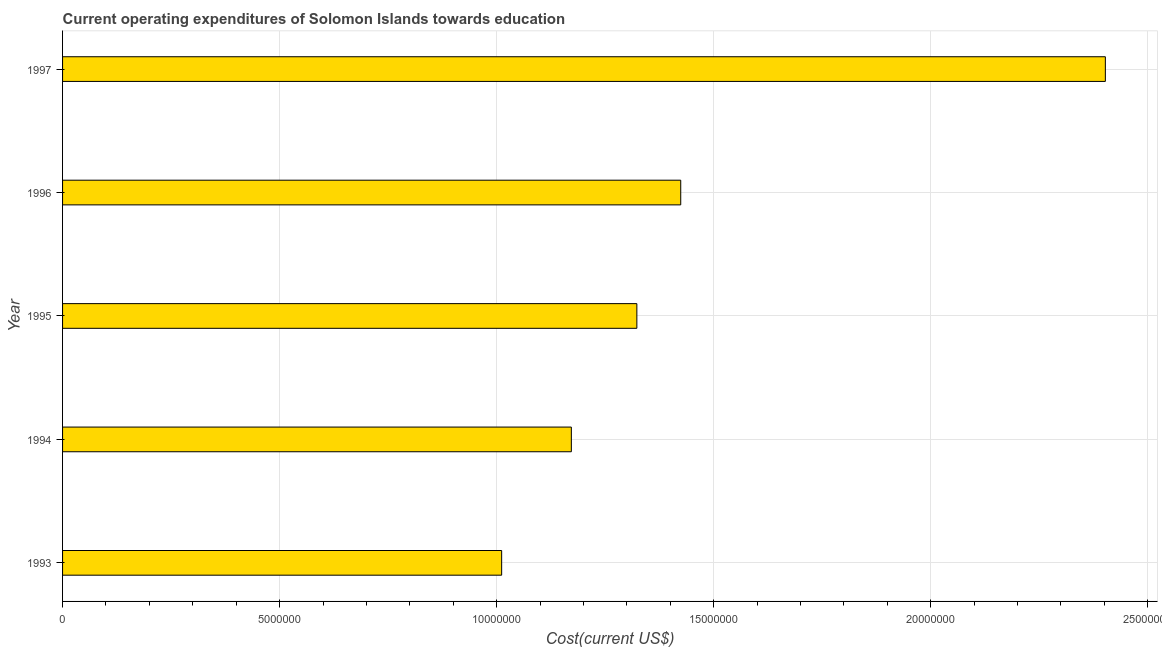Does the graph contain any zero values?
Ensure brevity in your answer.  No. Does the graph contain grids?
Your answer should be very brief. Yes. What is the title of the graph?
Your response must be concise. Current operating expenditures of Solomon Islands towards education. What is the label or title of the X-axis?
Give a very brief answer. Cost(current US$). What is the education expenditure in 1995?
Your answer should be compact. 1.32e+07. Across all years, what is the maximum education expenditure?
Offer a very short reply. 2.40e+07. Across all years, what is the minimum education expenditure?
Offer a very short reply. 1.01e+07. In which year was the education expenditure maximum?
Your response must be concise. 1997. What is the sum of the education expenditure?
Keep it short and to the point. 7.33e+07. What is the difference between the education expenditure in 1994 and 1996?
Make the answer very short. -2.52e+06. What is the average education expenditure per year?
Offer a terse response. 1.47e+07. What is the median education expenditure?
Make the answer very short. 1.32e+07. In how many years, is the education expenditure greater than 12000000 US$?
Offer a terse response. 3. What is the ratio of the education expenditure in 1994 to that in 1996?
Offer a very short reply. 0.82. Is the education expenditure in 1995 less than that in 1996?
Keep it short and to the point. Yes. Is the difference between the education expenditure in 1993 and 1997 greater than the difference between any two years?
Make the answer very short. Yes. What is the difference between the highest and the second highest education expenditure?
Your answer should be very brief. 9.78e+06. Is the sum of the education expenditure in 1994 and 1997 greater than the maximum education expenditure across all years?
Your response must be concise. Yes. What is the difference between the highest and the lowest education expenditure?
Your response must be concise. 1.39e+07. In how many years, is the education expenditure greater than the average education expenditure taken over all years?
Make the answer very short. 1. How many bars are there?
Provide a short and direct response. 5. How many years are there in the graph?
Your answer should be compact. 5. What is the difference between two consecutive major ticks on the X-axis?
Provide a short and direct response. 5.00e+06. What is the Cost(current US$) of 1993?
Provide a succinct answer. 1.01e+07. What is the Cost(current US$) of 1994?
Provide a succinct answer. 1.17e+07. What is the Cost(current US$) in 1995?
Your response must be concise. 1.32e+07. What is the Cost(current US$) in 1996?
Your response must be concise. 1.42e+07. What is the Cost(current US$) in 1997?
Provide a succinct answer. 2.40e+07. What is the difference between the Cost(current US$) in 1993 and 1994?
Your response must be concise. -1.61e+06. What is the difference between the Cost(current US$) in 1993 and 1995?
Provide a short and direct response. -3.11e+06. What is the difference between the Cost(current US$) in 1993 and 1996?
Keep it short and to the point. -4.13e+06. What is the difference between the Cost(current US$) in 1993 and 1997?
Your response must be concise. -1.39e+07. What is the difference between the Cost(current US$) in 1994 and 1995?
Offer a terse response. -1.51e+06. What is the difference between the Cost(current US$) in 1994 and 1996?
Offer a very short reply. -2.52e+06. What is the difference between the Cost(current US$) in 1994 and 1997?
Your answer should be very brief. -1.23e+07. What is the difference between the Cost(current US$) in 1995 and 1996?
Ensure brevity in your answer.  -1.01e+06. What is the difference between the Cost(current US$) in 1995 and 1997?
Keep it short and to the point. -1.08e+07. What is the difference between the Cost(current US$) in 1996 and 1997?
Offer a very short reply. -9.78e+06. What is the ratio of the Cost(current US$) in 1993 to that in 1994?
Ensure brevity in your answer.  0.86. What is the ratio of the Cost(current US$) in 1993 to that in 1995?
Make the answer very short. 0.77. What is the ratio of the Cost(current US$) in 1993 to that in 1996?
Give a very brief answer. 0.71. What is the ratio of the Cost(current US$) in 1993 to that in 1997?
Provide a short and direct response. 0.42. What is the ratio of the Cost(current US$) in 1994 to that in 1995?
Your answer should be compact. 0.89. What is the ratio of the Cost(current US$) in 1994 to that in 1996?
Offer a very short reply. 0.82. What is the ratio of the Cost(current US$) in 1994 to that in 1997?
Offer a terse response. 0.49. What is the ratio of the Cost(current US$) in 1995 to that in 1996?
Give a very brief answer. 0.93. What is the ratio of the Cost(current US$) in 1995 to that in 1997?
Ensure brevity in your answer.  0.55. What is the ratio of the Cost(current US$) in 1996 to that in 1997?
Your response must be concise. 0.59. 